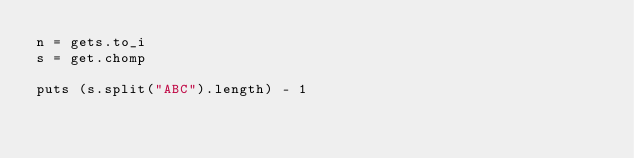<code> <loc_0><loc_0><loc_500><loc_500><_Ruby_>n = gets.to_i
s = get.chomp
 
puts (s.split("ABC").length) - 1 </code> 